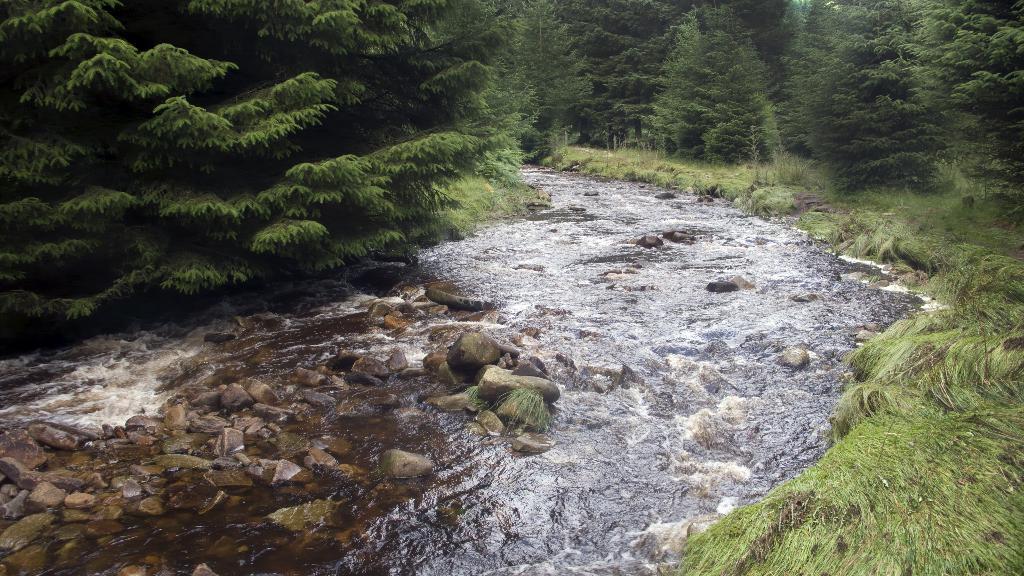In one or two sentences, can you explain what this image depicts? In this image we can see water, stones, few trees and grass. 